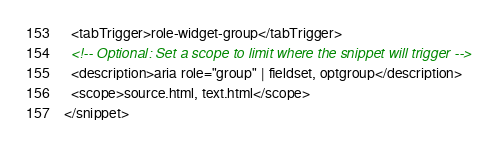<code> <loc_0><loc_0><loc_500><loc_500><_XML_>  <tabTrigger>role-widget-group</tabTrigger>
  <!-- Optional: Set a scope to limit where the snippet will trigger -->
  <description>aria role="group" | fieldset, optgroup</description>
  <scope>source.html, text.html</scope>
</snippet>
</code> 